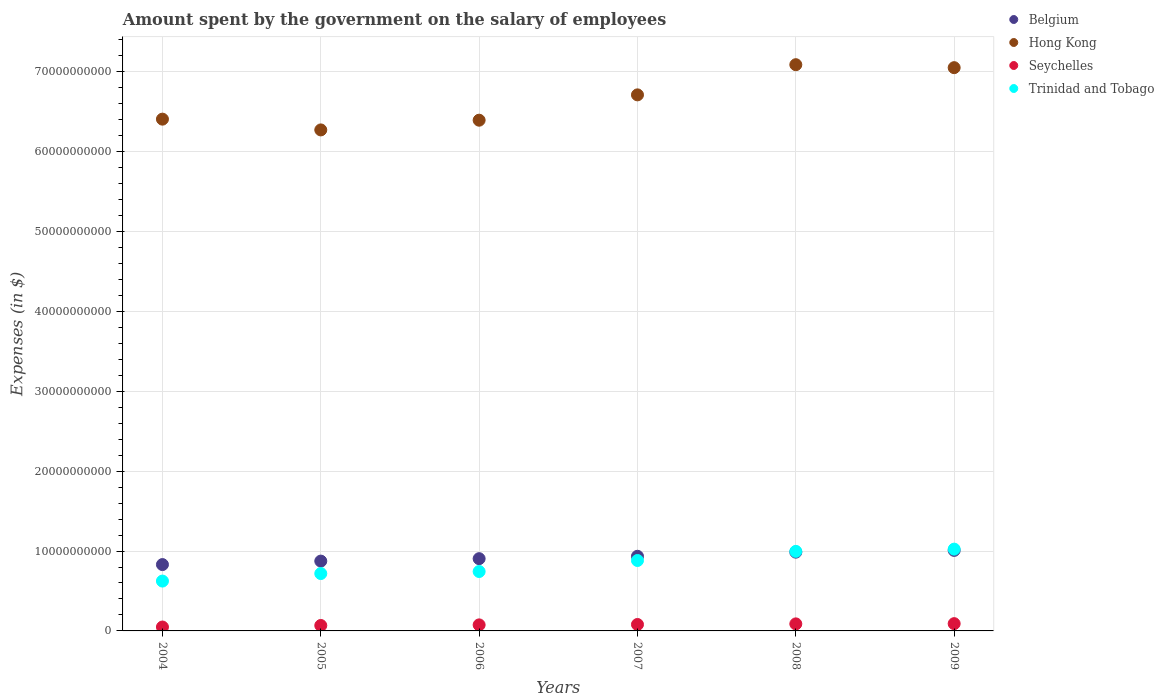Is the number of dotlines equal to the number of legend labels?
Give a very brief answer. Yes. What is the amount spent on the salary of employees by the government in Belgium in 2006?
Make the answer very short. 9.04e+09. Across all years, what is the maximum amount spent on the salary of employees by the government in Belgium?
Ensure brevity in your answer.  1.01e+1. Across all years, what is the minimum amount spent on the salary of employees by the government in Seychelles?
Make the answer very short. 4.88e+08. What is the total amount spent on the salary of employees by the government in Trinidad and Tobago in the graph?
Your answer should be very brief. 4.99e+1. What is the difference between the amount spent on the salary of employees by the government in Belgium in 2004 and that in 2009?
Provide a short and direct response. -1.77e+09. What is the difference between the amount spent on the salary of employees by the government in Hong Kong in 2006 and the amount spent on the salary of employees by the government in Seychelles in 2004?
Provide a short and direct response. 6.34e+1. What is the average amount spent on the salary of employees by the government in Seychelles per year?
Offer a very short reply. 7.54e+08. In the year 2007, what is the difference between the amount spent on the salary of employees by the government in Hong Kong and amount spent on the salary of employees by the government in Trinidad and Tobago?
Offer a terse response. 5.83e+1. In how many years, is the amount spent on the salary of employees by the government in Seychelles greater than 58000000000 $?
Offer a very short reply. 0. What is the ratio of the amount spent on the salary of employees by the government in Hong Kong in 2005 to that in 2006?
Provide a short and direct response. 0.98. Is the amount spent on the salary of employees by the government in Belgium in 2005 less than that in 2008?
Offer a terse response. Yes. Is the difference between the amount spent on the salary of employees by the government in Hong Kong in 2006 and 2008 greater than the difference between the amount spent on the salary of employees by the government in Trinidad and Tobago in 2006 and 2008?
Provide a succinct answer. No. What is the difference between the highest and the second highest amount spent on the salary of employees by the government in Hong Kong?
Keep it short and to the point. 3.72e+08. What is the difference between the highest and the lowest amount spent on the salary of employees by the government in Belgium?
Provide a short and direct response. 1.77e+09. In how many years, is the amount spent on the salary of employees by the government in Seychelles greater than the average amount spent on the salary of employees by the government in Seychelles taken over all years?
Your answer should be compact. 4. Is the sum of the amount spent on the salary of employees by the government in Trinidad and Tobago in 2006 and 2008 greater than the maximum amount spent on the salary of employees by the government in Seychelles across all years?
Your response must be concise. Yes. Is it the case that in every year, the sum of the amount spent on the salary of employees by the government in Trinidad and Tobago and amount spent on the salary of employees by the government in Hong Kong  is greater than the sum of amount spent on the salary of employees by the government in Belgium and amount spent on the salary of employees by the government in Seychelles?
Your response must be concise. Yes. Is it the case that in every year, the sum of the amount spent on the salary of employees by the government in Hong Kong and amount spent on the salary of employees by the government in Seychelles  is greater than the amount spent on the salary of employees by the government in Trinidad and Tobago?
Your response must be concise. Yes. Does the amount spent on the salary of employees by the government in Trinidad and Tobago monotonically increase over the years?
Make the answer very short. Yes. How many dotlines are there?
Ensure brevity in your answer.  4. Are the values on the major ticks of Y-axis written in scientific E-notation?
Offer a very short reply. No. Where does the legend appear in the graph?
Your response must be concise. Top right. How many legend labels are there?
Your answer should be very brief. 4. How are the legend labels stacked?
Provide a succinct answer. Vertical. What is the title of the graph?
Offer a terse response. Amount spent by the government on the salary of employees. What is the label or title of the X-axis?
Your answer should be very brief. Years. What is the label or title of the Y-axis?
Offer a very short reply. Expenses (in $). What is the Expenses (in $) in Belgium in 2004?
Provide a short and direct response. 8.30e+09. What is the Expenses (in $) of Hong Kong in 2004?
Your answer should be compact. 6.41e+1. What is the Expenses (in $) in Seychelles in 2004?
Your answer should be very brief. 4.88e+08. What is the Expenses (in $) of Trinidad and Tobago in 2004?
Provide a succinct answer. 6.24e+09. What is the Expenses (in $) of Belgium in 2005?
Provide a succinct answer. 8.74e+09. What is the Expenses (in $) in Hong Kong in 2005?
Your response must be concise. 6.27e+1. What is the Expenses (in $) of Seychelles in 2005?
Ensure brevity in your answer.  6.81e+08. What is the Expenses (in $) in Trinidad and Tobago in 2005?
Provide a short and direct response. 7.18e+09. What is the Expenses (in $) in Belgium in 2006?
Offer a very short reply. 9.04e+09. What is the Expenses (in $) of Hong Kong in 2006?
Provide a succinct answer. 6.39e+1. What is the Expenses (in $) of Seychelles in 2006?
Your response must be concise. 7.56e+08. What is the Expenses (in $) of Trinidad and Tobago in 2006?
Your answer should be very brief. 7.43e+09. What is the Expenses (in $) of Belgium in 2007?
Offer a very short reply. 9.34e+09. What is the Expenses (in $) of Hong Kong in 2007?
Offer a very short reply. 6.71e+1. What is the Expenses (in $) of Seychelles in 2007?
Your response must be concise. 8.06e+08. What is the Expenses (in $) in Trinidad and Tobago in 2007?
Offer a terse response. 8.81e+09. What is the Expenses (in $) in Belgium in 2008?
Keep it short and to the point. 9.86e+09. What is the Expenses (in $) of Hong Kong in 2008?
Provide a succinct answer. 7.09e+1. What is the Expenses (in $) of Seychelles in 2008?
Your answer should be very brief. 8.81e+08. What is the Expenses (in $) in Trinidad and Tobago in 2008?
Offer a very short reply. 9.96e+09. What is the Expenses (in $) of Belgium in 2009?
Ensure brevity in your answer.  1.01e+1. What is the Expenses (in $) of Hong Kong in 2009?
Keep it short and to the point. 7.05e+1. What is the Expenses (in $) in Seychelles in 2009?
Your answer should be compact. 9.11e+08. What is the Expenses (in $) in Trinidad and Tobago in 2009?
Make the answer very short. 1.02e+1. Across all years, what is the maximum Expenses (in $) in Belgium?
Give a very brief answer. 1.01e+1. Across all years, what is the maximum Expenses (in $) in Hong Kong?
Your response must be concise. 7.09e+1. Across all years, what is the maximum Expenses (in $) of Seychelles?
Your answer should be compact. 9.11e+08. Across all years, what is the maximum Expenses (in $) of Trinidad and Tobago?
Provide a succinct answer. 1.02e+1. Across all years, what is the minimum Expenses (in $) in Belgium?
Your answer should be very brief. 8.30e+09. Across all years, what is the minimum Expenses (in $) of Hong Kong?
Provide a short and direct response. 6.27e+1. Across all years, what is the minimum Expenses (in $) of Seychelles?
Give a very brief answer. 4.88e+08. Across all years, what is the minimum Expenses (in $) of Trinidad and Tobago?
Your answer should be very brief. 6.24e+09. What is the total Expenses (in $) in Belgium in the graph?
Offer a terse response. 5.54e+1. What is the total Expenses (in $) of Hong Kong in the graph?
Your answer should be compact. 3.99e+11. What is the total Expenses (in $) of Seychelles in the graph?
Offer a very short reply. 4.52e+09. What is the total Expenses (in $) of Trinidad and Tobago in the graph?
Offer a terse response. 4.99e+1. What is the difference between the Expenses (in $) of Belgium in 2004 and that in 2005?
Give a very brief answer. -4.35e+08. What is the difference between the Expenses (in $) in Hong Kong in 2004 and that in 2005?
Your answer should be very brief. 1.35e+09. What is the difference between the Expenses (in $) of Seychelles in 2004 and that in 2005?
Your answer should be very brief. -1.92e+08. What is the difference between the Expenses (in $) in Trinidad and Tobago in 2004 and that in 2005?
Your answer should be very brief. -9.41e+08. What is the difference between the Expenses (in $) in Belgium in 2004 and that in 2006?
Your response must be concise. -7.40e+08. What is the difference between the Expenses (in $) of Hong Kong in 2004 and that in 2006?
Your answer should be compact. 1.32e+08. What is the difference between the Expenses (in $) of Seychelles in 2004 and that in 2006?
Offer a terse response. -2.68e+08. What is the difference between the Expenses (in $) in Trinidad and Tobago in 2004 and that in 2006?
Offer a terse response. -1.20e+09. What is the difference between the Expenses (in $) of Belgium in 2004 and that in 2007?
Keep it short and to the point. -1.04e+09. What is the difference between the Expenses (in $) in Hong Kong in 2004 and that in 2007?
Your answer should be very brief. -3.04e+09. What is the difference between the Expenses (in $) of Seychelles in 2004 and that in 2007?
Your answer should be very brief. -3.17e+08. What is the difference between the Expenses (in $) in Trinidad and Tobago in 2004 and that in 2007?
Provide a short and direct response. -2.58e+09. What is the difference between the Expenses (in $) in Belgium in 2004 and that in 2008?
Your answer should be compact. -1.55e+09. What is the difference between the Expenses (in $) in Hong Kong in 2004 and that in 2008?
Your answer should be very brief. -6.82e+09. What is the difference between the Expenses (in $) of Seychelles in 2004 and that in 2008?
Keep it short and to the point. -3.92e+08. What is the difference between the Expenses (in $) of Trinidad and Tobago in 2004 and that in 2008?
Ensure brevity in your answer.  -3.72e+09. What is the difference between the Expenses (in $) in Belgium in 2004 and that in 2009?
Your answer should be very brief. -1.77e+09. What is the difference between the Expenses (in $) of Hong Kong in 2004 and that in 2009?
Offer a terse response. -6.44e+09. What is the difference between the Expenses (in $) in Seychelles in 2004 and that in 2009?
Your response must be concise. -4.23e+08. What is the difference between the Expenses (in $) of Trinidad and Tobago in 2004 and that in 2009?
Offer a terse response. -4.00e+09. What is the difference between the Expenses (in $) of Belgium in 2005 and that in 2006?
Ensure brevity in your answer.  -3.04e+08. What is the difference between the Expenses (in $) of Hong Kong in 2005 and that in 2006?
Make the answer very short. -1.22e+09. What is the difference between the Expenses (in $) of Seychelles in 2005 and that in 2006?
Provide a succinct answer. -7.54e+07. What is the difference between the Expenses (in $) in Trinidad and Tobago in 2005 and that in 2006?
Make the answer very short. -2.56e+08. What is the difference between the Expenses (in $) of Belgium in 2005 and that in 2007?
Ensure brevity in your answer.  -6.04e+08. What is the difference between the Expenses (in $) of Hong Kong in 2005 and that in 2007?
Keep it short and to the point. -4.39e+09. What is the difference between the Expenses (in $) of Seychelles in 2005 and that in 2007?
Keep it short and to the point. -1.25e+08. What is the difference between the Expenses (in $) of Trinidad and Tobago in 2005 and that in 2007?
Provide a short and direct response. -1.64e+09. What is the difference between the Expenses (in $) in Belgium in 2005 and that in 2008?
Make the answer very short. -1.12e+09. What is the difference between the Expenses (in $) in Hong Kong in 2005 and that in 2008?
Your answer should be compact. -8.16e+09. What is the difference between the Expenses (in $) in Seychelles in 2005 and that in 2008?
Keep it short and to the point. -2.00e+08. What is the difference between the Expenses (in $) in Trinidad and Tobago in 2005 and that in 2008?
Your answer should be compact. -2.78e+09. What is the difference between the Expenses (in $) of Belgium in 2005 and that in 2009?
Ensure brevity in your answer.  -1.34e+09. What is the difference between the Expenses (in $) in Hong Kong in 2005 and that in 2009?
Make the answer very short. -7.79e+09. What is the difference between the Expenses (in $) of Seychelles in 2005 and that in 2009?
Offer a very short reply. -2.31e+08. What is the difference between the Expenses (in $) in Trinidad and Tobago in 2005 and that in 2009?
Your answer should be compact. -3.06e+09. What is the difference between the Expenses (in $) of Belgium in 2006 and that in 2007?
Make the answer very short. -2.99e+08. What is the difference between the Expenses (in $) of Hong Kong in 2006 and that in 2007?
Your answer should be very brief. -3.17e+09. What is the difference between the Expenses (in $) of Seychelles in 2006 and that in 2007?
Give a very brief answer. -4.97e+07. What is the difference between the Expenses (in $) in Trinidad and Tobago in 2006 and that in 2007?
Give a very brief answer. -1.38e+09. What is the difference between the Expenses (in $) of Belgium in 2006 and that in 2008?
Provide a succinct answer. -8.14e+08. What is the difference between the Expenses (in $) of Hong Kong in 2006 and that in 2008?
Your answer should be compact. -6.95e+09. What is the difference between the Expenses (in $) in Seychelles in 2006 and that in 2008?
Your answer should be very brief. -1.25e+08. What is the difference between the Expenses (in $) in Trinidad and Tobago in 2006 and that in 2008?
Provide a succinct answer. -2.52e+09. What is the difference between the Expenses (in $) of Belgium in 2006 and that in 2009?
Keep it short and to the point. -1.03e+09. What is the difference between the Expenses (in $) of Hong Kong in 2006 and that in 2009?
Offer a terse response. -6.58e+09. What is the difference between the Expenses (in $) in Seychelles in 2006 and that in 2009?
Keep it short and to the point. -1.55e+08. What is the difference between the Expenses (in $) of Trinidad and Tobago in 2006 and that in 2009?
Offer a terse response. -2.80e+09. What is the difference between the Expenses (in $) in Belgium in 2007 and that in 2008?
Ensure brevity in your answer.  -5.14e+08. What is the difference between the Expenses (in $) of Hong Kong in 2007 and that in 2008?
Provide a succinct answer. -3.78e+09. What is the difference between the Expenses (in $) of Seychelles in 2007 and that in 2008?
Provide a short and direct response. -7.49e+07. What is the difference between the Expenses (in $) of Trinidad and Tobago in 2007 and that in 2008?
Give a very brief answer. -1.14e+09. What is the difference between the Expenses (in $) in Belgium in 2007 and that in 2009?
Your answer should be very brief. -7.34e+08. What is the difference between the Expenses (in $) in Hong Kong in 2007 and that in 2009?
Provide a succinct answer. -3.40e+09. What is the difference between the Expenses (in $) in Seychelles in 2007 and that in 2009?
Make the answer very short. -1.05e+08. What is the difference between the Expenses (in $) of Trinidad and Tobago in 2007 and that in 2009?
Your answer should be very brief. -1.42e+09. What is the difference between the Expenses (in $) in Belgium in 2008 and that in 2009?
Keep it short and to the point. -2.20e+08. What is the difference between the Expenses (in $) of Hong Kong in 2008 and that in 2009?
Provide a short and direct response. 3.72e+08. What is the difference between the Expenses (in $) of Seychelles in 2008 and that in 2009?
Keep it short and to the point. -3.04e+07. What is the difference between the Expenses (in $) in Trinidad and Tobago in 2008 and that in 2009?
Make the answer very short. -2.80e+08. What is the difference between the Expenses (in $) in Belgium in 2004 and the Expenses (in $) in Hong Kong in 2005?
Offer a terse response. -5.44e+1. What is the difference between the Expenses (in $) in Belgium in 2004 and the Expenses (in $) in Seychelles in 2005?
Offer a terse response. 7.62e+09. What is the difference between the Expenses (in $) of Belgium in 2004 and the Expenses (in $) of Trinidad and Tobago in 2005?
Your answer should be compact. 1.12e+09. What is the difference between the Expenses (in $) of Hong Kong in 2004 and the Expenses (in $) of Seychelles in 2005?
Offer a very short reply. 6.34e+1. What is the difference between the Expenses (in $) of Hong Kong in 2004 and the Expenses (in $) of Trinidad and Tobago in 2005?
Keep it short and to the point. 5.69e+1. What is the difference between the Expenses (in $) of Seychelles in 2004 and the Expenses (in $) of Trinidad and Tobago in 2005?
Give a very brief answer. -6.69e+09. What is the difference between the Expenses (in $) of Belgium in 2004 and the Expenses (in $) of Hong Kong in 2006?
Your response must be concise. -5.56e+1. What is the difference between the Expenses (in $) of Belgium in 2004 and the Expenses (in $) of Seychelles in 2006?
Provide a short and direct response. 7.55e+09. What is the difference between the Expenses (in $) in Belgium in 2004 and the Expenses (in $) in Trinidad and Tobago in 2006?
Give a very brief answer. 8.68e+08. What is the difference between the Expenses (in $) in Hong Kong in 2004 and the Expenses (in $) in Seychelles in 2006?
Provide a short and direct response. 6.33e+1. What is the difference between the Expenses (in $) in Hong Kong in 2004 and the Expenses (in $) in Trinidad and Tobago in 2006?
Provide a short and direct response. 5.66e+1. What is the difference between the Expenses (in $) of Seychelles in 2004 and the Expenses (in $) of Trinidad and Tobago in 2006?
Keep it short and to the point. -6.95e+09. What is the difference between the Expenses (in $) in Belgium in 2004 and the Expenses (in $) in Hong Kong in 2007?
Make the answer very short. -5.88e+1. What is the difference between the Expenses (in $) of Belgium in 2004 and the Expenses (in $) of Seychelles in 2007?
Provide a succinct answer. 7.50e+09. What is the difference between the Expenses (in $) in Belgium in 2004 and the Expenses (in $) in Trinidad and Tobago in 2007?
Make the answer very short. -5.11e+08. What is the difference between the Expenses (in $) in Hong Kong in 2004 and the Expenses (in $) in Seychelles in 2007?
Make the answer very short. 6.32e+1. What is the difference between the Expenses (in $) of Hong Kong in 2004 and the Expenses (in $) of Trinidad and Tobago in 2007?
Provide a short and direct response. 5.52e+1. What is the difference between the Expenses (in $) of Seychelles in 2004 and the Expenses (in $) of Trinidad and Tobago in 2007?
Ensure brevity in your answer.  -8.33e+09. What is the difference between the Expenses (in $) of Belgium in 2004 and the Expenses (in $) of Hong Kong in 2008?
Offer a very short reply. -6.26e+1. What is the difference between the Expenses (in $) in Belgium in 2004 and the Expenses (in $) in Seychelles in 2008?
Offer a very short reply. 7.42e+09. What is the difference between the Expenses (in $) in Belgium in 2004 and the Expenses (in $) in Trinidad and Tobago in 2008?
Offer a terse response. -1.65e+09. What is the difference between the Expenses (in $) in Hong Kong in 2004 and the Expenses (in $) in Seychelles in 2008?
Provide a short and direct response. 6.32e+1. What is the difference between the Expenses (in $) in Hong Kong in 2004 and the Expenses (in $) in Trinidad and Tobago in 2008?
Provide a succinct answer. 5.41e+1. What is the difference between the Expenses (in $) in Seychelles in 2004 and the Expenses (in $) in Trinidad and Tobago in 2008?
Give a very brief answer. -9.47e+09. What is the difference between the Expenses (in $) of Belgium in 2004 and the Expenses (in $) of Hong Kong in 2009?
Your answer should be very brief. -6.22e+1. What is the difference between the Expenses (in $) of Belgium in 2004 and the Expenses (in $) of Seychelles in 2009?
Offer a terse response. 7.39e+09. What is the difference between the Expenses (in $) in Belgium in 2004 and the Expenses (in $) in Trinidad and Tobago in 2009?
Offer a very short reply. -1.93e+09. What is the difference between the Expenses (in $) of Hong Kong in 2004 and the Expenses (in $) of Seychelles in 2009?
Your answer should be compact. 6.31e+1. What is the difference between the Expenses (in $) of Hong Kong in 2004 and the Expenses (in $) of Trinidad and Tobago in 2009?
Your response must be concise. 5.38e+1. What is the difference between the Expenses (in $) of Seychelles in 2004 and the Expenses (in $) of Trinidad and Tobago in 2009?
Offer a very short reply. -9.75e+09. What is the difference between the Expenses (in $) in Belgium in 2005 and the Expenses (in $) in Hong Kong in 2006?
Your answer should be very brief. -5.52e+1. What is the difference between the Expenses (in $) of Belgium in 2005 and the Expenses (in $) of Seychelles in 2006?
Make the answer very short. 7.98e+09. What is the difference between the Expenses (in $) in Belgium in 2005 and the Expenses (in $) in Trinidad and Tobago in 2006?
Your response must be concise. 1.30e+09. What is the difference between the Expenses (in $) of Hong Kong in 2005 and the Expenses (in $) of Seychelles in 2006?
Keep it short and to the point. 6.19e+1. What is the difference between the Expenses (in $) in Hong Kong in 2005 and the Expenses (in $) in Trinidad and Tobago in 2006?
Provide a succinct answer. 5.53e+1. What is the difference between the Expenses (in $) in Seychelles in 2005 and the Expenses (in $) in Trinidad and Tobago in 2006?
Give a very brief answer. -6.75e+09. What is the difference between the Expenses (in $) of Belgium in 2005 and the Expenses (in $) of Hong Kong in 2007?
Provide a succinct answer. -5.84e+1. What is the difference between the Expenses (in $) of Belgium in 2005 and the Expenses (in $) of Seychelles in 2007?
Keep it short and to the point. 7.93e+09. What is the difference between the Expenses (in $) in Belgium in 2005 and the Expenses (in $) in Trinidad and Tobago in 2007?
Make the answer very short. -7.57e+07. What is the difference between the Expenses (in $) of Hong Kong in 2005 and the Expenses (in $) of Seychelles in 2007?
Make the answer very short. 6.19e+1. What is the difference between the Expenses (in $) of Hong Kong in 2005 and the Expenses (in $) of Trinidad and Tobago in 2007?
Offer a very short reply. 5.39e+1. What is the difference between the Expenses (in $) of Seychelles in 2005 and the Expenses (in $) of Trinidad and Tobago in 2007?
Offer a terse response. -8.13e+09. What is the difference between the Expenses (in $) of Belgium in 2005 and the Expenses (in $) of Hong Kong in 2008?
Give a very brief answer. -6.21e+1. What is the difference between the Expenses (in $) of Belgium in 2005 and the Expenses (in $) of Seychelles in 2008?
Provide a succinct answer. 7.86e+09. What is the difference between the Expenses (in $) in Belgium in 2005 and the Expenses (in $) in Trinidad and Tobago in 2008?
Provide a short and direct response. -1.22e+09. What is the difference between the Expenses (in $) in Hong Kong in 2005 and the Expenses (in $) in Seychelles in 2008?
Your answer should be very brief. 6.18e+1. What is the difference between the Expenses (in $) of Hong Kong in 2005 and the Expenses (in $) of Trinidad and Tobago in 2008?
Your answer should be compact. 5.27e+1. What is the difference between the Expenses (in $) of Seychelles in 2005 and the Expenses (in $) of Trinidad and Tobago in 2008?
Ensure brevity in your answer.  -9.28e+09. What is the difference between the Expenses (in $) of Belgium in 2005 and the Expenses (in $) of Hong Kong in 2009?
Keep it short and to the point. -6.18e+1. What is the difference between the Expenses (in $) of Belgium in 2005 and the Expenses (in $) of Seychelles in 2009?
Your answer should be very brief. 7.83e+09. What is the difference between the Expenses (in $) in Belgium in 2005 and the Expenses (in $) in Trinidad and Tobago in 2009?
Provide a succinct answer. -1.50e+09. What is the difference between the Expenses (in $) of Hong Kong in 2005 and the Expenses (in $) of Seychelles in 2009?
Offer a very short reply. 6.18e+1. What is the difference between the Expenses (in $) of Hong Kong in 2005 and the Expenses (in $) of Trinidad and Tobago in 2009?
Offer a very short reply. 5.25e+1. What is the difference between the Expenses (in $) in Seychelles in 2005 and the Expenses (in $) in Trinidad and Tobago in 2009?
Provide a succinct answer. -9.56e+09. What is the difference between the Expenses (in $) of Belgium in 2006 and the Expenses (in $) of Hong Kong in 2007?
Offer a terse response. -5.80e+1. What is the difference between the Expenses (in $) of Belgium in 2006 and the Expenses (in $) of Seychelles in 2007?
Your answer should be compact. 8.24e+09. What is the difference between the Expenses (in $) of Belgium in 2006 and the Expenses (in $) of Trinidad and Tobago in 2007?
Provide a succinct answer. 2.29e+08. What is the difference between the Expenses (in $) in Hong Kong in 2006 and the Expenses (in $) in Seychelles in 2007?
Offer a terse response. 6.31e+1. What is the difference between the Expenses (in $) of Hong Kong in 2006 and the Expenses (in $) of Trinidad and Tobago in 2007?
Make the answer very short. 5.51e+1. What is the difference between the Expenses (in $) of Seychelles in 2006 and the Expenses (in $) of Trinidad and Tobago in 2007?
Ensure brevity in your answer.  -8.06e+09. What is the difference between the Expenses (in $) of Belgium in 2006 and the Expenses (in $) of Hong Kong in 2008?
Offer a terse response. -6.18e+1. What is the difference between the Expenses (in $) in Belgium in 2006 and the Expenses (in $) in Seychelles in 2008?
Your answer should be compact. 8.16e+09. What is the difference between the Expenses (in $) in Belgium in 2006 and the Expenses (in $) in Trinidad and Tobago in 2008?
Your answer should be very brief. -9.14e+08. What is the difference between the Expenses (in $) in Hong Kong in 2006 and the Expenses (in $) in Seychelles in 2008?
Provide a short and direct response. 6.30e+1. What is the difference between the Expenses (in $) in Hong Kong in 2006 and the Expenses (in $) in Trinidad and Tobago in 2008?
Your answer should be very brief. 5.40e+1. What is the difference between the Expenses (in $) of Seychelles in 2006 and the Expenses (in $) of Trinidad and Tobago in 2008?
Your response must be concise. -9.20e+09. What is the difference between the Expenses (in $) of Belgium in 2006 and the Expenses (in $) of Hong Kong in 2009?
Offer a terse response. -6.15e+1. What is the difference between the Expenses (in $) of Belgium in 2006 and the Expenses (in $) of Seychelles in 2009?
Provide a short and direct response. 8.13e+09. What is the difference between the Expenses (in $) in Belgium in 2006 and the Expenses (in $) in Trinidad and Tobago in 2009?
Give a very brief answer. -1.19e+09. What is the difference between the Expenses (in $) in Hong Kong in 2006 and the Expenses (in $) in Seychelles in 2009?
Your answer should be compact. 6.30e+1. What is the difference between the Expenses (in $) in Hong Kong in 2006 and the Expenses (in $) in Trinidad and Tobago in 2009?
Provide a short and direct response. 5.37e+1. What is the difference between the Expenses (in $) in Seychelles in 2006 and the Expenses (in $) in Trinidad and Tobago in 2009?
Offer a terse response. -9.48e+09. What is the difference between the Expenses (in $) in Belgium in 2007 and the Expenses (in $) in Hong Kong in 2008?
Provide a short and direct response. -6.15e+1. What is the difference between the Expenses (in $) of Belgium in 2007 and the Expenses (in $) of Seychelles in 2008?
Make the answer very short. 8.46e+09. What is the difference between the Expenses (in $) of Belgium in 2007 and the Expenses (in $) of Trinidad and Tobago in 2008?
Your response must be concise. -6.14e+08. What is the difference between the Expenses (in $) of Hong Kong in 2007 and the Expenses (in $) of Seychelles in 2008?
Make the answer very short. 6.62e+1. What is the difference between the Expenses (in $) in Hong Kong in 2007 and the Expenses (in $) in Trinidad and Tobago in 2008?
Make the answer very short. 5.71e+1. What is the difference between the Expenses (in $) in Seychelles in 2007 and the Expenses (in $) in Trinidad and Tobago in 2008?
Give a very brief answer. -9.15e+09. What is the difference between the Expenses (in $) in Belgium in 2007 and the Expenses (in $) in Hong Kong in 2009?
Provide a succinct answer. -6.12e+1. What is the difference between the Expenses (in $) of Belgium in 2007 and the Expenses (in $) of Seychelles in 2009?
Ensure brevity in your answer.  8.43e+09. What is the difference between the Expenses (in $) of Belgium in 2007 and the Expenses (in $) of Trinidad and Tobago in 2009?
Offer a terse response. -8.95e+08. What is the difference between the Expenses (in $) in Hong Kong in 2007 and the Expenses (in $) in Seychelles in 2009?
Your answer should be very brief. 6.62e+1. What is the difference between the Expenses (in $) in Hong Kong in 2007 and the Expenses (in $) in Trinidad and Tobago in 2009?
Your answer should be very brief. 5.69e+1. What is the difference between the Expenses (in $) of Seychelles in 2007 and the Expenses (in $) of Trinidad and Tobago in 2009?
Your response must be concise. -9.43e+09. What is the difference between the Expenses (in $) in Belgium in 2008 and the Expenses (in $) in Hong Kong in 2009?
Provide a short and direct response. -6.06e+1. What is the difference between the Expenses (in $) in Belgium in 2008 and the Expenses (in $) in Seychelles in 2009?
Offer a very short reply. 8.95e+09. What is the difference between the Expenses (in $) in Belgium in 2008 and the Expenses (in $) in Trinidad and Tobago in 2009?
Keep it short and to the point. -3.80e+08. What is the difference between the Expenses (in $) of Hong Kong in 2008 and the Expenses (in $) of Seychelles in 2009?
Provide a short and direct response. 7.00e+1. What is the difference between the Expenses (in $) of Hong Kong in 2008 and the Expenses (in $) of Trinidad and Tobago in 2009?
Ensure brevity in your answer.  6.06e+1. What is the difference between the Expenses (in $) of Seychelles in 2008 and the Expenses (in $) of Trinidad and Tobago in 2009?
Provide a succinct answer. -9.36e+09. What is the average Expenses (in $) in Belgium per year?
Give a very brief answer. 9.23e+09. What is the average Expenses (in $) of Hong Kong per year?
Your response must be concise. 6.65e+1. What is the average Expenses (in $) of Seychelles per year?
Keep it short and to the point. 7.54e+08. What is the average Expenses (in $) in Trinidad and Tobago per year?
Your answer should be compact. 8.31e+09. In the year 2004, what is the difference between the Expenses (in $) in Belgium and Expenses (in $) in Hong Kong?
Provide a succinct answer. -5.57e+1. In the year 2004, what is the difference between the Expenses (in $) in Belgium and Expenses (in $) in Seychelles?
Provide a short and direct response. 7.81e+09. In the year 2004, what is the difference between the Expenses (in $) of Belgium and Expenses (in $) of Trinidad and Tobago?
Ensure brevity in your answer.  2.06e+09. In the year 2004, what is the difference between the Expenses (in $) in Hong Kong and Expenses (in $) in Seychelles?
Make the answer very short. 6.36e+1. In the year 2004, what is the difference between the Expenses (in $) of Hong Kong and Expenses (in $) of Trinidad and Tobago?
Your answer should be compact. 5.78e+1. In the year 2004, what is the difference between the Expenses (in $) of Seychelles and Expenses (in $) of Trinidad and Tobago?
Give a very brief answer. -5.75e+09. In the year 2005, what is the difference between the Expenses (in $) of Belgium and Expenses (in $) of Hong Kong?
Your response must be concise. -5.40e+1. In the year 2005, what is the difference between the Expenses (in $) in Belgium and Expenses (in $) in Seychelles?
Provide a short and direct response. 8.06e+09. In the year 2005, what is the difference between the Expenses (in $) in Belgium and Expenses (in $) in Trinidad and Tobago?
Offer a terse response. 1.56e+09. In the year 2005, what is the difference between the Expenses (in $) of Hong Kong and Expenses (in $) of Seychelles?
Your answer should be compact. 6.20e+1. In the year 2005, what is the difference between the Expenses (in $) of Hong Kong and Expenses (in $) of Trinidad and Tobago?
Keep it short and to the point. 5.55e+1. In the year 2005, what is the difference between the Expenses (in $) in Seychelles and Expenses (in $) in Trinidad and Tobago?
Offer a very short reply. -6.50e+09. In the year 2006, what is the difference between the Expenses (in $) in Belgium and Expenses (in $) in Hong Kong?
Your answer should be very brief. -5.49e+1. In the year 2006, what is the difference between the Expenses (in $) of Belgium and Expenses (in $) of Seychelles?
Offer a terse response. 8.29e+09. In the year 2006, what is the difference between the Expenses (in $) in Belgium and Expenses (in $) in Trinidad and Tobago?
Your answer should be very brief. 1.61e+09. In the year 2006, what is the difference between the Expenses (in $) of Hong Kong and Expenses (in $) of Seychelles?
Keep it short and to the point. 6.32e+1. In the year 2006, what is the difference between the Expenses (in $) of Hong Kong and Expenses (in $) of Trinidad and Tobago?
Offer a terse response. 5.65e+1. In the year 2006, what is the difference between the Expenses (in $) of Seychelles and Expenses (in $) of Trinidad and Tobago?
Your response must be concise. -6.68e+09. In the year 2007, what is the difference between the Expenses (in $) in Belgium and Expenses (in $) in Hong Kong?
Keep it short and to the point. -5.77e+1. In the year 2007, what is the difference between the Expenses (in $) in Belgium and Expenses (in $) in Seychelles?
Your response must be concise. 8.54e+09. In the year 2007, what is the difference between the Expenses (in $) in Belgium and Expenses (in $) in Trinidad and Tobago?
Provide a succinct answer. 5.28e+08. In the year 2007, what is the difference between the Expenses (in $) of Hong Kong and Expenses (in $) of Seychelles?
Give a very brief answer. 6.63e+1. In the year 2007, what is the difference between the Expenses (in $) of Hong Kong and Expenses (in $) of Trinidad and Tobago?
Ensure brevity in your answer.  5.83e+1. In the year 2007, what is the difference between the Expenses (in $) of Seychelles and Expenses (in $) of Trinidad and Tobago?
Provide a succinct answer. -8.01e+09. In the year 2008, what is the difference between the Expenses (in $) in Belgium and Expenses (in $) in Hong Kong?
Your response must be concise. -6.10e+1. In the year 2008, what is the difference between the Expenses (in $) in Belgium and Expenses (in $) in Seychelles?
Offer a very short reply. 8.98e+09. In the year 2008, what is the difference between the Expenses (in $) in Belgium and Expenses (in $) in Trinidad and Tobago?
Make the answer very short. -1.00e+08. In the year 2008, what is the difference between the Expenses (in $) of Hong Kong and Expenses (in $) of Seychelles?
Make the answer very short. 7.00e+1. In the year 2008, what is the difference between the Expenses (in $) in Hong Kong and Expenses (in $) in Trinidad and Tobago?
Give a very brief answer. 6.09e+1. In the year 2008, what is the difference between the Expenses (in $) in Seychelles and Expenses (in $) in Trinidad and Tobago?
Keep it short and to the point. -9.08e+09. In the year 2009, what is the difference between the Expenses (in $) of Belgium and Expenses (in $) of Hong Kong?
Ensure brevity in your answer.  -6.04e+1. In the year 2009, what is the difference between the Expenses (in $) in Belgium and Expenses (in $) in Seychelles?
Make the answer very short. 9.17e+09. In the year 2009, what is the difference between the Expenses (in $) of Belgium and Expenses (in $) of Trinidad and Tobago?
Your answer should be very brief. -1.60e+08. In the year 2009, what is the difference between the Expenses (in $) in Hong Kong and Expenses (in $) in Seychelles?
Offer a very short reply. 6.96e+1. In the year 2009, what is the difference between the Expenses (in $) of Hong Kong and Expenses (in $) of Trinidad and Tobago?
Your answer should be compact. 6.03e+1. In the year 2009, what is the difference between the Expenses (in $) of Seychelles and Expenses (in $) of Trinidad and Tobago?
Keep it short and to the point. -9.33e+09. What is the ratio of the Expenses (in $) in Belgium in 2004 to that in 2005?
Offer a very short reply. 0.95. What is the ratio of the Expenses (in $) of Hong Kong in 2004 to that in 2005?
Make the answer very short. 1.02. What is the ratio of the Expenses (in $) in Seychelles in 2004 to that in 2005?
Your answer should be very brief. 0.72. What is the ratio of the Expenses (in $) in Trinidad and Tobago in 2004 to that in 2005?
Make the answer very short. 0.87. What is the ratio of the Expenses (in $) of Belgium in 2004 to that in 2006?
Your answer should be compact. 0.92. What is the ratio of the Expenses (in $) in Seychelles in 2004 to that in 2006?
Your response must be concise. 0.65. What is the ratio of the Expenses (in $) of Trinidad and Tobago in 2004 to that in 2006?
Your response must be concise. 0.84. What is the ratio of the Expenses (in $) in Belgium in 2004 to that in 2007?
Give a very brief answer. 0.89. What is the ratio of the Expenses (in $) in Hong Kong in 2004 to that in 2007?
Give a very brief answer. 0.95. What is the ratio of the Expenses (in $) of Seychelles in 2004 to that in 2007?
Offer a terse response. 0.61. What is the ratio of the Expenses (in $) of Trinidad and Tobago in 2004 to that in 2007?
Give a very brief answer. 0.71. What is the ratio of the Expenses (in $) in Belgium in 2004 to that in 2008?
Make the answer very short. 0.84. What is the ratio of the Expenses (in $) in Hong Kong in 2004 to that in 2008?
Your answer should be very brief. 0.9. What is the ratio of the Expenses (in $) in Seychelles in 2004 to that in 2008?
Offer a very short reply. 0.55. What is the ratio of the Expenses (in $) of Trinidad and Tobago in 2004 to that in 2008?
Provide a succinct answer. 0.63. What is the ratio of the Expenses (in $) of Belgium in 2004 to that in 2009?
Ensure brevity in your answer.  0.82. What is the ratio of the Expenses (in $) in Hong Kong in 2004 to that in 2009?
Offer a very short reply. 0.91. What is the ratio of the Expenses (in $) in Seychelles in 2004 to that in 2009?
Offer a terse response. 0.54. What is the ratio of the Expenses (in $) of Trinidad and Tobago in 2004 to that in 2009?
Your answer should be compact. 0.61. What is the ratio of the Expenses (in $) in Belgium in 2005 to that in 2006?
Offer a very short reply. 0.97. What is the ratio of the Expenses (in $) in Hong Kong in 2005 to that in 2006?
Your answer should be very brief. 0.98. What is the ratio of the Expenses (in $) of Seychelles in 2005 to that in 2006?
Your answer should be very brief. 0.9. What is the ratio of the Expenses (in $) of Trinidad and Tobago in 2005 to that in 2006?
Ensure brevity in your answer.  0.97. What is the ratio of the Expenses (in $) in Belgium in 2005 to that in 2007?
Your answer should be compact. 0.94. What is the ratio of the Expenses (in $) of Hong Kong in 2005 to that in 2007?
Provide a short and direct response. 0.93. What is the ratio of the Expenses (in $) of Seychelles in 2005 to that in 2007?
Provide a succinct answer. 0.84. What is the ratio of the Expenses (in $) in Trinidad and Tobago in 2005 to that in 2007?
Give a very brief answer. 0.81. What is the ratio of the Expenses (in $) in Belgium in 2005 to that in 2008?
Give a very brief answer. 0.89. What is the ratio of the Expenses (in $) in Hong Kong in 2005 to that in 2008?
Your answer should be compact. 0.88. What is the ratio of the Expenses (in $) in Seychelles in 2005 to that in 2008?
Keep it short and to the point. 0.77. What is the ratio of the Expenses (in $) of Trinidad and Tobago in 2005 to that in 2008?
Your answer should be compact. 0.72. What is the ratio of the Expenses (in $) in Belgium in 2005 to that in 2009?
Offer a terse response. 0.87. What is the ratio of the Expenses (in $) of Hong Kong in 2005 to that in 2009?
Offer a terse response. 0.89. What is the ratio of the Expenses (in $) of Seychelles in 2005 to that in 2009?
Your answer should be very brief. 0.75. What is the ratio of the Expenses (in $) of Trinidad and Tobago in 2005 to that in 2009?
Your response must be concise. 0.7. What is the ratio of the Expenses (in $) in Belgium in 2006 to that in 2007?
Offer a very short reply. 0.97. What is the ratio of the Expenses (in $) of Hong Kong in 2006 to that in 2007?
Keep it short and to the point. 0.95. What is the ratio of the Expenses (in $) of Seychelles in 2006 to that in 2007?
Keep it short and to the point. 0.94. What is the ratio of the Expenses (in $) in Trinidad and Tobago in 2006 to that in 2007?
Offer a very short reply. 0.84. What is the ratio of the Expenses (in $) in Belgium in 2006 to that in 2008?
Offer a very short reply. 0.92. What is the ratio of the Expenses (in $) in Hong Kong in 2006 to that in 2008?
Offer a terse response. 0.9. What is the ratio of the Expenses (in $) in Seychelles in 2006 to that in 2008?
Offer a very short reply. 0.86. What is the ratio of the Expenses (in $) of Trinidad and Tobago in 2006 to that in 2008?
Ensure brevity in your answer.  0.75. What is the ratio of the Expenses (in $) of Belgium in 2006 to that in 2009?
Make the answer very short. 0.9. What is the ratio of the Expenses (in $) of Hong Kong in 2006 to that in 2009?
Keep it short and to the point. 0.91. What is the ratio of the Expenses (in $) in Seychelles in 2006 to that in 2009?
Provide a succinct answer. 0.83. What is the ratio of the Expenses (in $) in Trinidad and Tobago in 2006 to that in 2009?
Keep it short and to the point. 0.73. What is the ratio of the Expenses (in $) in Belgium in 2007 to that in 2008?
Give a very brief answer. 0.95. What is the ratio of the Expenses (in $) of Hong Kong in 2007 to that in 2008?
Your answer should be very brief. 0.95. What is the ratio of the Expenses (in $) in Seychelles in 2007 to that in 2008?
Provide a succinct answer. 0.91. What is the ratio of the Expenses (in $) in Trinidad and Tobago in 2007 to that in 2008?
Ensure brevity in your answer.  0.89. What is the ratio of the Expenses (in $) of Belgium in 2007 to that in 2009?
Offer a very short reply. 0.93. What is the ratio of the Expenses (in $) in Hong Kong in 2007 to that in 2009?
Offer a terse response. 0.95. What is the ratio of the Expenses (in $) in Seychelles in 2007 to that in 2009?
Offer a very short reply. 0.88. What is the ratio of the Expenses (in $) of Trinidad and Tobago in 2007 to that in 2009?
Your answer should be very brief. 0.86. What is the ratio of the Expenses (in $) in Belgium in 2008 to that in 2009?
Your answer should be very brief. 0.98. What is the ratio of the Expenses (in $) of Hong Kong in 2008 to that in 2009?
Provide a succinct answer. 1.01. What is the ratio of the Expenses (in $) of Seychelles in 2008 to that in 2009?
Give a very brief answer. 0.97. What is the ratio of the Expenses (in $) of Trinidad and Tobago in 2008 to that in 2009?
Keep it short and to the point. 0.97. What is the difference between the highest and the second highest Expenses (in $) in Belgium?
Provide a short and direct response. 2.20e+08. What is the difference between the highest and the second highest Expenses (in $) in Hong Kong?
Your response must be concise. 3.72e+08. What is the difference between the highest and the second highest Expenses (in $) in Seychelles?
Keep it short and to the point. 3.04e+07. What is the difference between the highest and the second highest Expenses (in $) in Trinidad and Tobago?
Keep it short and to the point. 2.80e+08. What is the difference between the highest and the lowest Expenses (in $) of Belgium?
Your answer should be compact. 1.77e+09. What is the difference between the highest and the lowest Expenses (in $) of Hong Kong?
Keep it short and to the point. 8.16e+09. What is the difference between the highest and the lowest Expenses (in $) of Seychelles?
Offer a very short reply. 4.23e+08. What is the difference between the highest and the lowest Expenses (in $) in Trinidad and Tobago?
Give a very brief answer. 4.00e+09. 